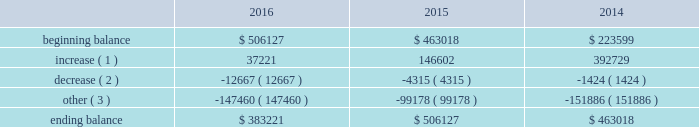The principal components of eog's rollforward of valuation allowances for deferred tax assets were as follows ( in thousands ) : .
( 1 ) increase in valuation allowance related to the generation of tax net operating losses and other deferred tax assets .
( 2 ) decrease in valuation allowance associated with adjustments to certain deferred tax assets and their related allowance .
( 3 ) represents dispositions/revisions/foreign exchange rate variances and the effect of statutory income tax rate changes .
The balance of unrecognized tax benefits at december 31 , 2016 , was $ 36 million , of which $ 2 million may potentially have an earnings impact .
Eog records interest and penalties related to unrecognized tax benefits to its income tax provision .
Currently , $ 2 million of interest has been recognized in the consolidated statements of income and comprehensive income .
Eog does not anticipate that the amount of the unrecognized tax benefits will significantly change during the next twelve months .
Eog and its subsidiaries file income tax returns and are subject to tax audits in the united states and various state , local and foreign jurisdictions .
Eog's earliest open tax years in its principal jurisdictions are as follows : united states federal ( 2011 ) , canada ( 2012 ) , united kingdom ( 2015 ) , trinidad ( 2010 ) and china ( 2008 ) .
Eog's foreign subsidiaries' undistributed earnings of approximately $ 2 billion at december 31 , 2016 , are no longer considered to be permanently reinvested outside the united states and , accordingly , eog has cumulatively recorded $ 280 million of united states federal , foreign and state deferred income taxes .
Eog changed its permanent reinvestment assertion in 2014 .
In 2016 , eog's alternative minimum tax ( amt ) credits were reduced by $ 21 million mostly as a result of carry-back claims and certain elections .
Remaining amt credits of $ 758 million , resulting from amt paid in prior years , will be carried forward indefinitely until they are used to offset regular income taxes in future periods .
The ability of eog to utilize these amt credit carryforwards to reduce federal income taxes may become subject to various limitations under the internal revenue code .
Such limitations may arise if certain ownership changes ( as defined for income tax purposes ) were to occur .
As of december 31 , 2016 , eog had state income tax net operating losses ( nols ) being carried forward of approximately $ 1.6 billion , which , if unused , expire between 2017 and 2035 .
During 2016 , eog's united kingdom subsidiary incurred a tax nol of approximately $ 38 million which , along with prior years' nols of $ 740 million , will be carried forward indefinitely .
As described above , these nols have been evaluated for the likelihood of future utilization , and valuation allowances have been established for the portion of these deferred tax assets that do not meet the "more likely than not" threshold .
Employee benefit plans stock-based compensation during 2016 , eog maintained various stock-based compensation plans as discussed below .
Eog recognizes compensation expense on grants of stock options , sars , restricted stock and restricted stock units , performance units and performance stock , and grants made under the eog resources , inc .
Employee stock purchase plan ( espp ) .
Stock-based compensation expense is calculated based upon the grant date estimated fair value of the awards , net of forfeitures , based upon eog's historical employee turnover rate .
Compensation expense is amortized over the shorter of the vesting period or the period from date of grant until the date the employee becomes eligible to retire without company approval. .
Considering the balance of unrecognized tax benefits in 2016 , what is the percentage of the potential of tax benefits that may have an earnings impact? 
Rationale: it is the amount of cash related to tax benefits that may have an earnings impact divided by the total unrecognized tax benefits .
Computations: (2 / 36)
Answer: 0.05556. 